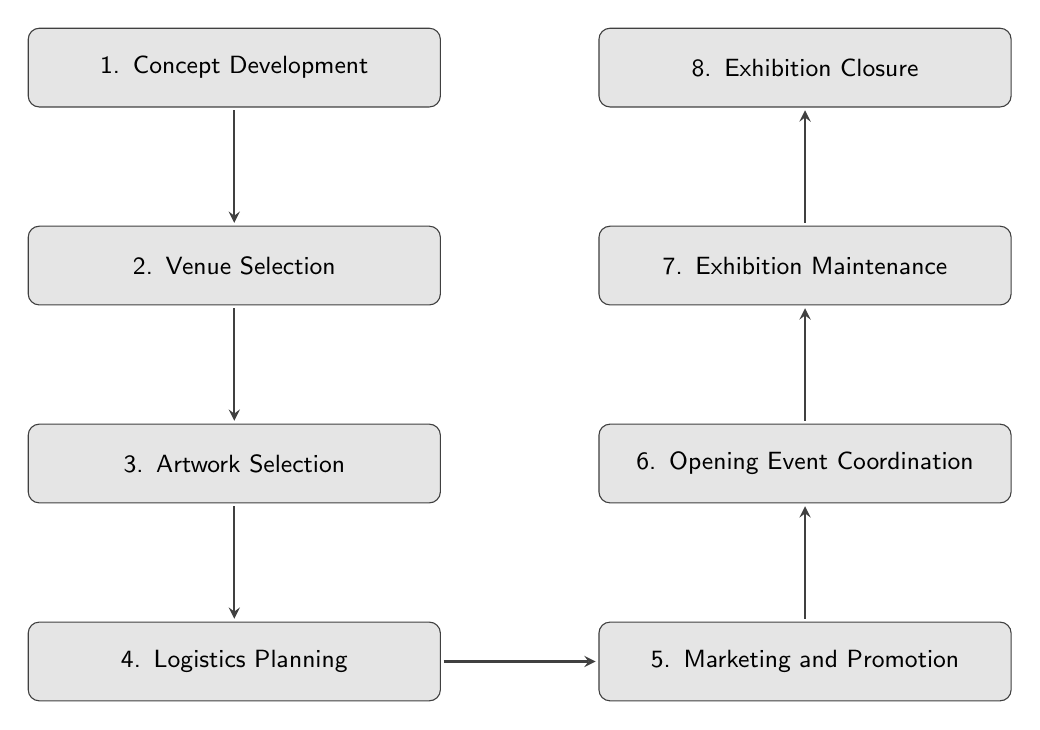What is the first step in the process? The first step in the diagram is "Concept Development," which is labeled clearly at the top.
Answer: Concept Development How many steps are in the exhibition setup process? By counting the nodes in the diagram, there are a total of eight distinct steps represented.
Answer: Eight What step follows "Logistics Planning"? According to the flow of the diagram, the step that directly follows "Logistics Planning" is "Marketing and Promotion."
Answer: Marketing and Promotion Which step involves selecting artworks? The diagram indicates that "Artwork Selection" is the designated step for choosing the artworks for the exhibition.
Answer: Artwork Selection What are the last two steps of the exhibition process? The final two steps in the diagram, moving upward, are "Exhibition Maintenance" and "Exhibition Closure," respectively.
Answer: Exhibition Maintenance, Exhibition Closure Which steps are involved after "Venue Selection"? After "Venue Selection," the subsequent steps are "Artwork Selection," "Logistics Planning," and "Marketing and Promotion." These are sequentially connected in the diagram.
Answer: Artwork Selection, Logistics Planning, Marketing and Promotion What is the main purpose of the "Marketing and Promotion" step? The description for "Marketing and Promotion" indicates its goal is to promote the exhibition to attract visitors, as outlined in the diagram.
Answer: Promote to attract visitors Which step includes organizing catering? In the flow, "Opening Event Coordination" includes tasks related to planning the opening event, specifically mentioning the organization of catering.
Answer: Opening Event Coordination 